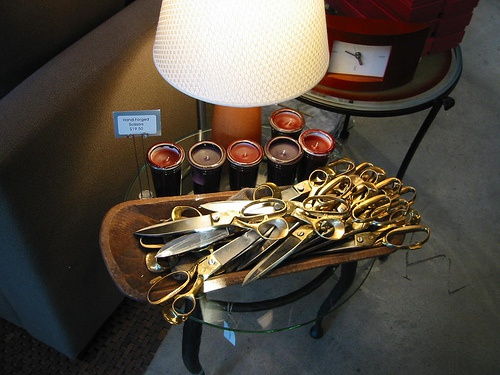Describe the objects in this image and their specific colors. I can see scissors in black, maroon, tan, and khaki tones, scissors in black, darkgray, ivory, gray, and tan tones, scissors in black, ivory, maroon, and olive tones, scissors in black, olive, and maroon tones, and clock in black, darkgray, and gray tones in this image. 